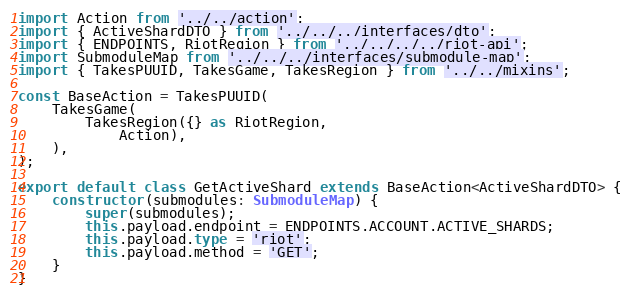<code> <loc_0><loc_0><loc_500><loc_500><_TypeScript_>import Action from '../../action';
import { ActiveShardDTO } from '../../../interfaces/dto';
import { ENDPOINTS, RiotRegion } from '../../../../riot-api';
import SubmoduleMap from '../../../interfaces/submodule-map';
import { TakesPUUID, TakesGame, TakesRegion } from '../../mixins';

const BaseAction = TakesPUUID(
    TakesGame(
        TakesRegion({} as RiotRegion,
            Action),
    ),
);

export default class GetActiveShard extends BaseAction<ActiveShardDTO> {
    constructor(submodules: SubmoduleMap) {
        super(submodules);
        this.payload.endpoint = ENDPOINTS.ACCOUNT.ACTIVE_SHARDS;
        this.payload.type = 'riot';
        this.payload.method = 'GET';
    }
}
</code> 